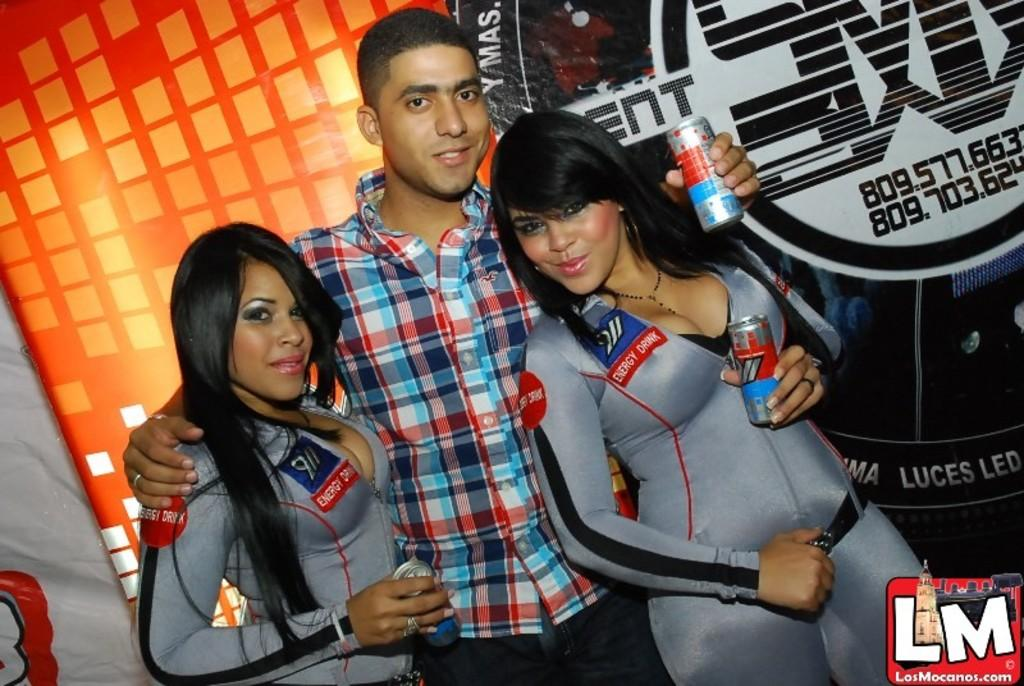How many people are in the foreground of the picture? There are two women and a man in the foreground of the picture. What is the man holding in the image? The man is holding tins in the image. Is there any text or symbol in the bottom right corner of the image? Yes, there is a logo in the bottom right corner of the image. What can be seen in the background of the image? There is a banner in the background of the image. What type of magic is the man performing with the tins in the image? There is no magic being performed in the image; the man is simply holding tins. How does the mother feel about the scene in the image? There is no mention of a mother in the image, so it is impossible to determine her feelings about the scene. 